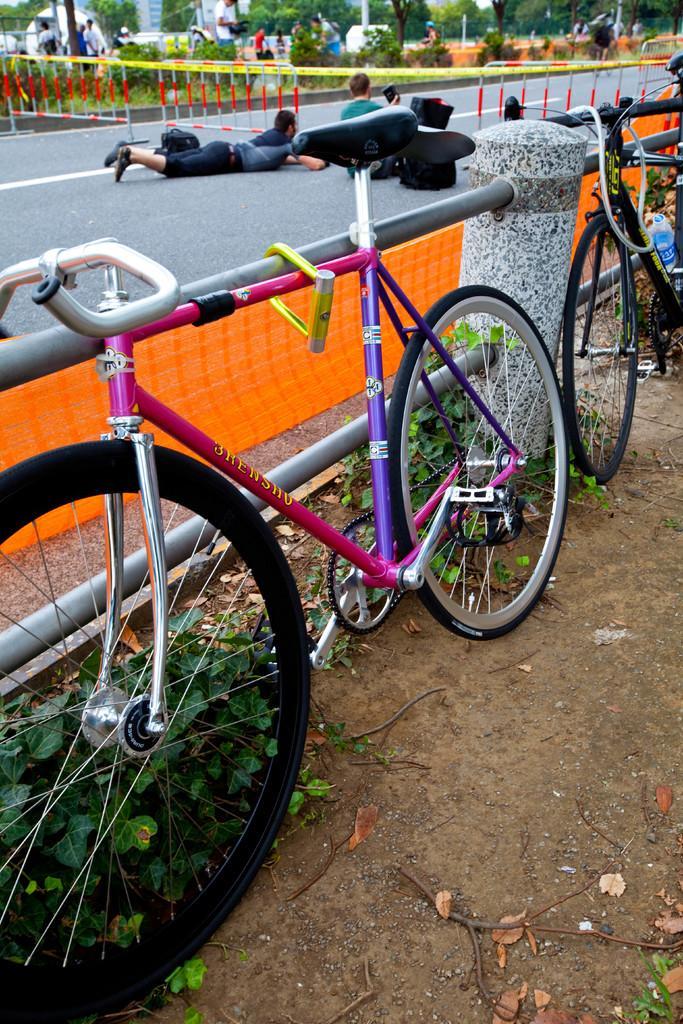How would you summarize this image in a sentence or two? On the left side of the image there is a road. On the road there are a few people sitting and one boy is laid on the road, beside the road there is a fencing. On the left side of the road there are some trees and a few people standing. On the right side of the image there is a path with fencing and two bicycles are attached to the fencing and some plants are on the path of a ground. 